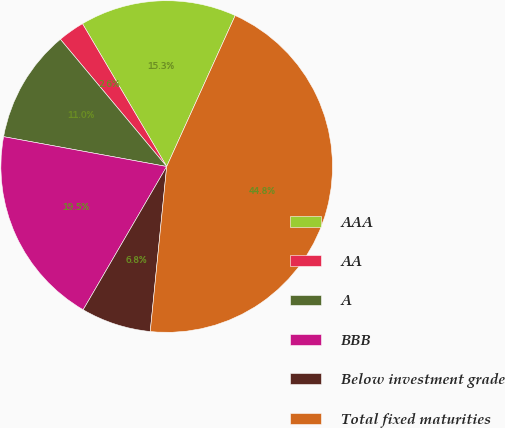<chart> <loc_0><loc_0><loc_500><loc_500><pie_chart><fcel>AAA<fcel>AA<fcel>A<fcel>BBB<fcel>Below investment grade<fcel>Total fixed maturities<nl><fcel>15.26%<fcel>2.6%<fcel>11.04%<fcel>19.48%<fcel>6.82%<fcel>44.8%<nl></chart> 